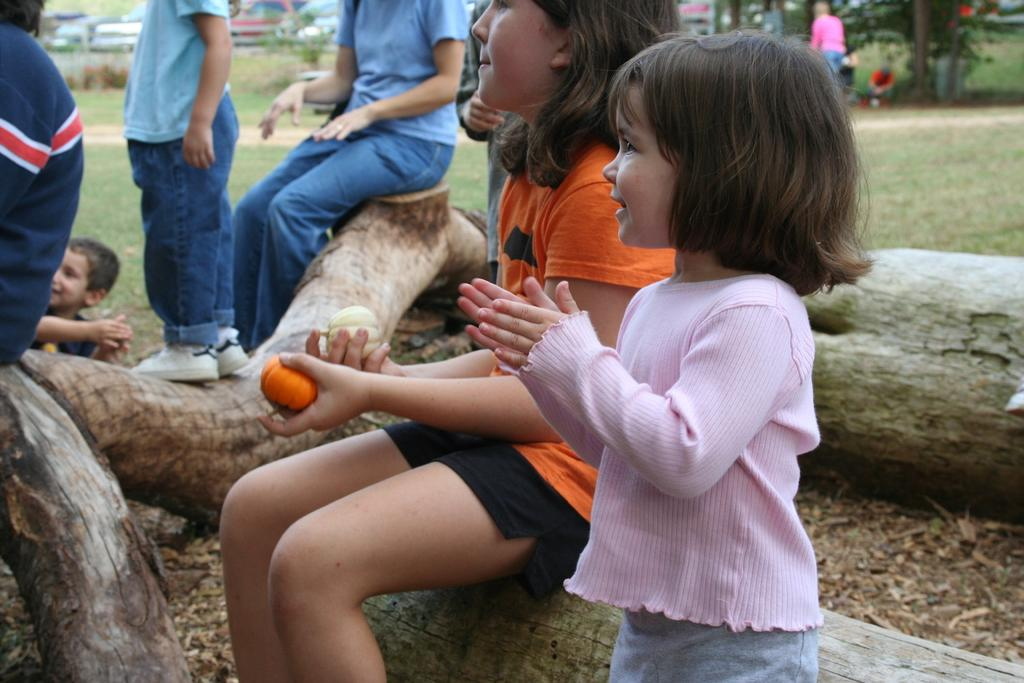What type of vegetation can be seen in the image? There are tree stems in the image. Are there any living beings in the image? Yes, there are people in the image. What type of ground cover is present in the image? There is grass in the image. What can be seen in the distance in the image? Cars are visible in the background of the image. What type of cork can be seen floating in the water in the image? There is no water or cork present in the image. How many nuts are being cracked by the people in the image? There are no nuts or nut-cracking activity depicted in the image. 